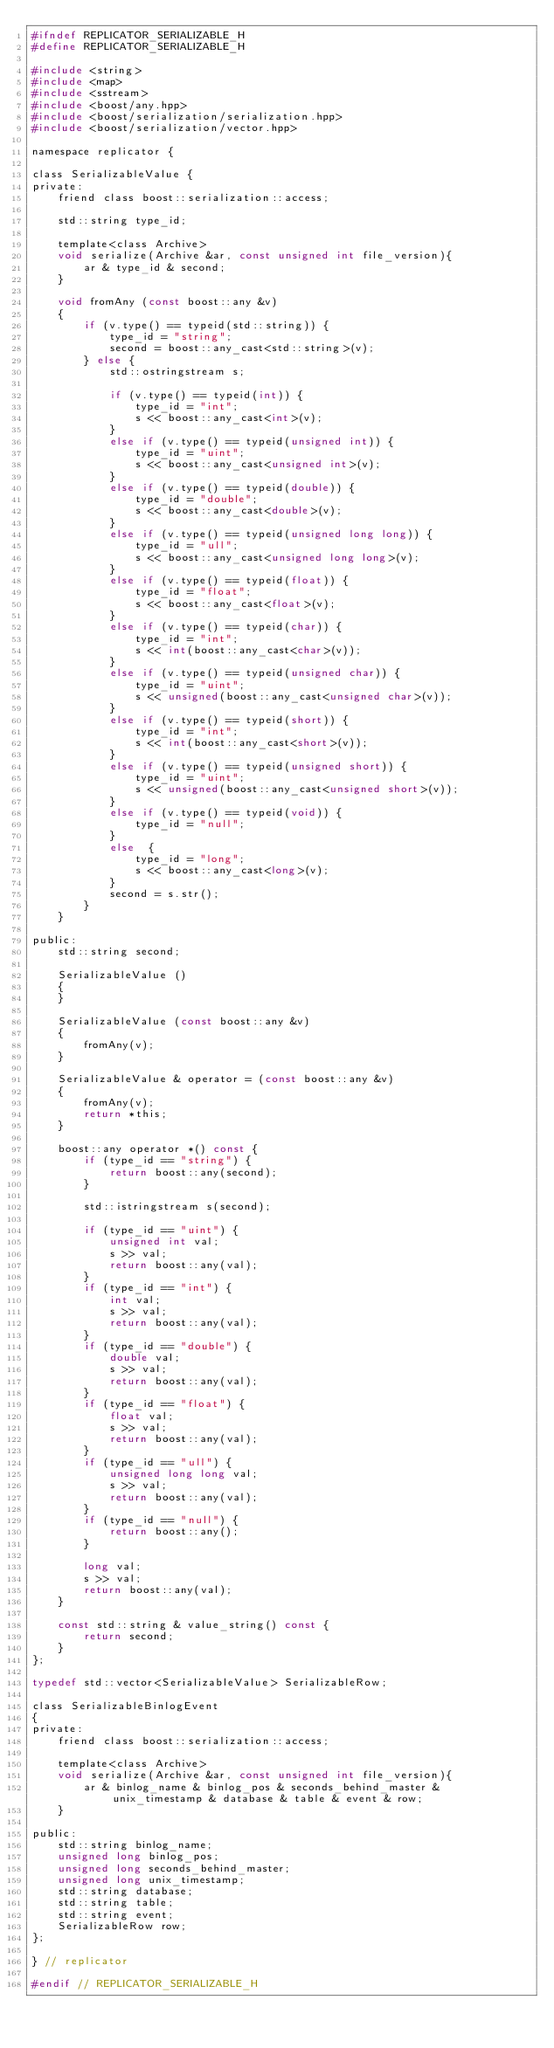<code> <loc_0><loc_0><loc_500><loc_500><_C_>#ifndef REPLICATOR_SERIALIZABLE_H
#define REPLICATOR_SERIALIZABLE_H

#include <string>
#include <map>
#include <sstream>
#include <boost/any.hpp>
#include <boost/serialization/serialization.hpp>
#include <boost/serialization/vector.hpp>

namespace replicator {

class SerializableValue {
private:
	friend class boost::serialization::access;

	std::string type_id;

	template<class Archive>
	void serialize(Archive &ar, const unsigned int file_version){
		ar & type_id & second;
	}

	void fromAny (const boost::any &v)
	{
		if (v.type() == typeid(std::string)) {
			type_id = "string";
			second = boost::any_cast<std::string>(v);
		} else {
			std::ostringstream s;

			if (v.type() == typeid(int)) {
				type_id = "int";
				s << boost::any_cast<int>(v);
			}
			else if (v.type() == typeid(unsigned int)) {
				type_id = "uint";
				s << boost::any_cast<unsigned int>(v);
			}
			else if (v.type() == typeid(double)) {
				type_id = "double";
				s << boost::any_cast<double>(v);
			}
			else if (v.type() == typeid(unsigned long long)) {
				type_id = "ull";
				s << boost::any_cast<unsigned long long>(v);
			}
			else if (v.type() == typeid(float)) {
				type_id = "float";
				s << boost::any_cast<float>(v);
			}
			else if (v.type() == typeid(char)) {
				type_id = "int";
				s << int(boost::any_cast<char>(v));
			}
			else if (v.type() == typeid(unsigned char)) {
				type_id = "uint";
				s << unsigned(boost::any_cast<unsigned char>(v));
			}
			else if (v.type() == typeid(short)) {
				type_id = "int";
				s << int(boost::any_cast<short>(v));
			}
			else if (v.type() == typeid(unsigned short)) {
				type_id = "uint";
				s << unsigned(boost::any_cast<unsigned short>(v));
			}
			else if (v.type() == typeid(void)) {
				type_id = "null";
			}
			else  {
				type_id = "long";
				s << boost::any_cast<long>(v);
			}
			second = s.str();
		}
	}

public:
	std::string second;

	SerializableValue ()
	{
	}

	SerializableValue (const boost::any &v)
	{
		fromAny(v);
	}

	SerializableValue & operator = (const boost::any &v)
	{
		fromAny(v);
		return *this;
	}

	boost::any operator *() const {
		if (type_id == "string") {
			return boost::any(second);
		}

		std::istringstream s(second);

		if (type_id == "uint") {
			unsigned int val;
			s >> val;
			return boost::any(val);
		}
		if (type_id == "int") {
			int val;
			s >> val;
			return boost::any(val);
		}
		if (type_id == "double") {
			double val;
			s >> val;
			return boost::any(val);
		}
		if (type_id == "float") {
			float val;
			s >> val;
			return boost::any(val);
		}
		if (type_id == "ull") {
			unsigned long long val;
			s >> val;
			return boost::any(val);
		}
		if (type_id == "null") {
			return boost::any();
		}

		long val;
		s >> val;
		return boost::any(val);
	}

	const std::string & value_string() const {
		return second;
	}
};

typedef std::vector<SerializableValue> SerializableRow;

class SerializableBinlogEvent
{
private:
	friend class boost::serialization::access;

	template<class Archive>
	void serialize(Archive &ar, const unsigned int file_version){
		ar & binlog_name & binlog_pos & seconds_behind_master & unix_timestamp & database & table & event & row;
	}

public:
	std::string binlog_name;
	unsigned long binlog_pos;
	unsigned long seconds_behind_master;
	unsigned long unix_timestamp;
	std::string database;
	std::string table;
	std::string event;
	SerializableRow row;
};

} // replicator

#endif // REPLICATOR_SERIALIZABLE_H
</code> 